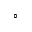Convert formula to latex. <formula><loc_0><loc_0><loc_500><loc_500>\circ</formula> 